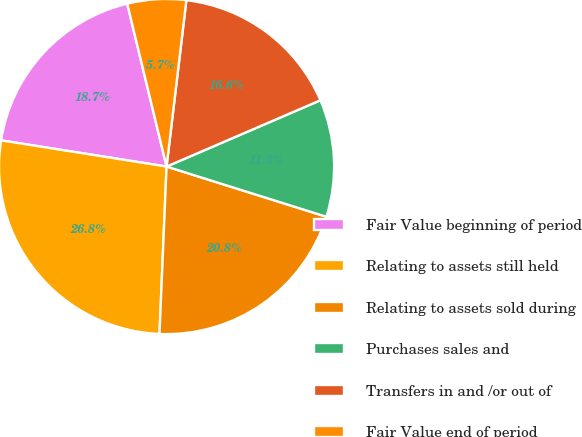<chart> <loc_0><loc_0><loc_500><loc_500><pie_chart><fcel>Fair Value beginning of period<fcel>Relating to assets still held<fcel>Relating to assets sold during<fcel>Purchases sales and<fcel>Transfers in and /or out of<fcel>Fair Value end of period<nl><fcel>18.73%<fcel>26.83%<fcel>20.83%<fcel>11.32%<fcel>16.64%<fcel>5.66%<nl></chart> 